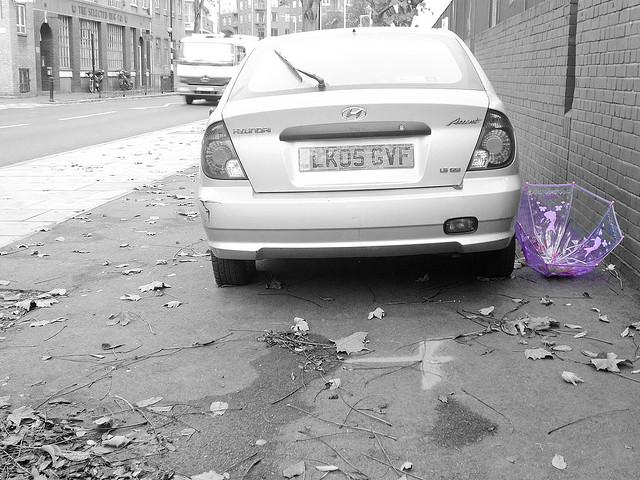Is this car parked?
Write a very short answer. Yes. What item is in color?
Answer briefly. Umbrella. What is the object between the car and the brick wall?
Quick response, please. Umbrella. 